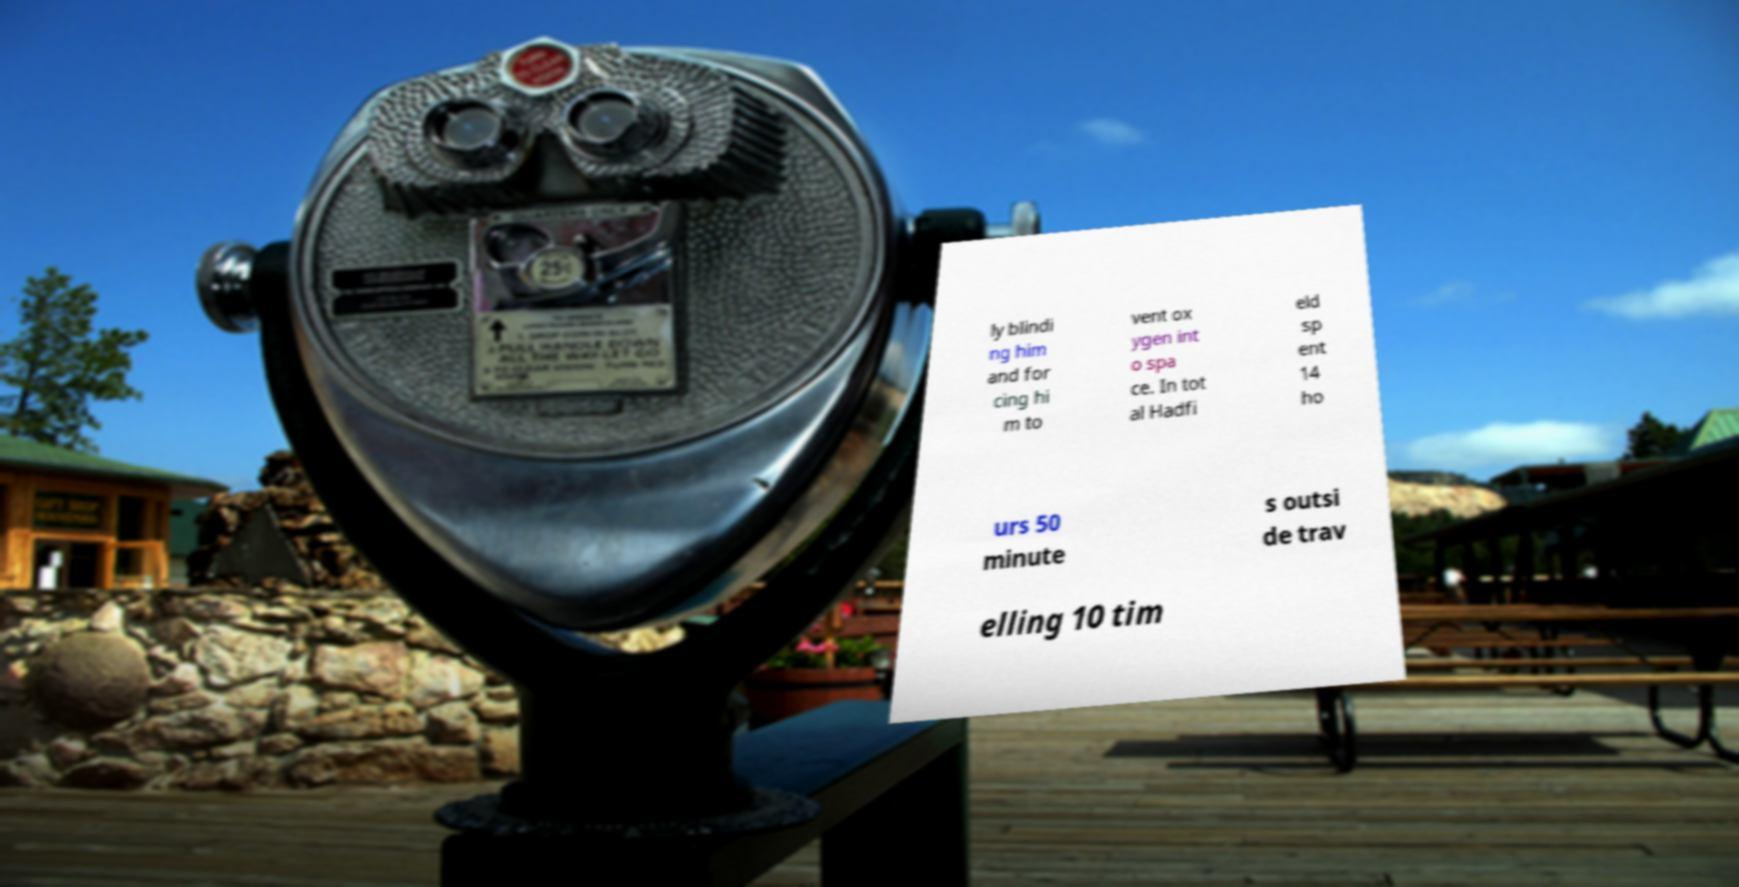There's text embedded in this image that I need extracted. Can you transcribe it verbatim? ly blindi ng him and for cing hi m to vent ox ygen int o spa ce. In tot al Hadfi eld sp ent 14 ho urs 50 minute s outsi de trav elling 10 tim 